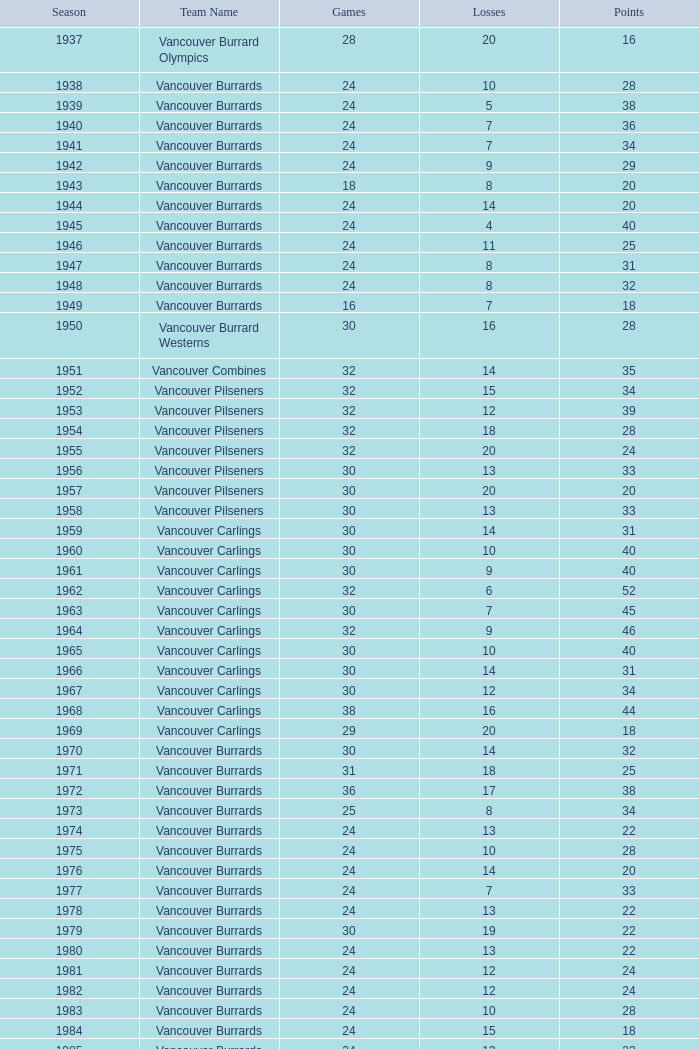Give me the full table as a dictionary. {'header': ['Season', 'Team Name', 'Games', 'Losses', 'Points'], 'rows': [['1937', 'Vancouver Burrard Olympics', '28', '20', '16'], ['1938', 'Vancouver Burrards', '24', '10', '28'], ['1939', 'Vancouver Burrards', '24', '5', '38'], ['1940', 'Vancouver Burrards', '24', '7', '36'], ['1941', 'Vancouver Burrards', '24', '7', '34'], ['1942', 'Vancouver Burrards', '24', '9', '29'], ['1943', 'Vancouver Burrards', '18', '8', '20'], ['1944', 'Vancouver Burrards', '24', '14', '20'], ['1945', 'Vancouver Burrards', '24', '4', '40'], ['1946', 'Vancouver Burrards', '24', '11', '25'], ['1947', 'Vancouver Burrards', '24', '8', '31'], ['1948', 'Vancouver Burrards', '24', '8', '32'], ['1949', 'Vancouver Burrards', '16', '7', '18'], ['1950', 'Vancouver Burrard Westerns', '30', '16', '28'], ['1951', 'Vancouver Combines', '32', '14', '35'], ['1952', 'Vancouver Pilseners', '32', '15', '34'], ['1953', 'Vancouver Pilseners', '32', '12', '39'], ['1954', 'Vancouver Pilseners', '32', '18', '28'], ['1955', 'Vancouver Pilseners', '32', '20', '24'], ['1956', 'Vancouver Pilseners', '30', '13', '33'], ['1957', 'Vancouver Pilseners', '30', '20', '20'], ['1958', 'Vancouver Pilseners', '30', '13', '33'], ['1959', 'Vancouver Carlings', '30', '14', '31'], ['1960', 'Vancouver Carlings', '30', '10', '40'], ['1961', 'Vancouver Carlings', '30', '9', '40'], ['1962', 'Vancouver Carlings', '32', '6', '52'], ['1963', 'Vancouver Carlings', '30', '7', '45'], ['1964', 'Vancouver Carlings', '32', '9', '46'], ['1965', 'Vancouver Carlings', '30', '10', '40'], ['1966', 'Vancouver Carlings', '30', '14', '31'], ['1967', 'Vancouver Carlings', '30', '12', '34'], ['1968', 'Vancouver Carlings', '38', '16', '44'], ['1969', 'Vancouver Carlings', '29', '20', '18'], ['1970', 'Vancouver Burrards', '30', '14', '32'], ['1971', 'Vancouver Burrards', '31', '18', '25'], ['1972', 'Vancouver Burrards', '36', '17', '38'], ['1973', 'Vancouver Burrards', '25', '8', '34'], ['1974', 'Vancouver Burrards', '24', '13', '22'], ['1975', 'Vancouver Burrards', '24', '10', '28'], ['1976', 'Vancouver Burrards', '24', '14', '20'], ['1977', 'Vancouver Burrards', '24', '7', '33'], ['1978', 'Vancouver Burrards', '24', '13', '22'], ['1979', 'Vancouver Burrards', '30', '19', '22'], ['1980', 'Vancouver Burrards', '24', '13', '22'], ['1981', 'Vancouver Burrards', '24', '12', '24'], ['1982', 'Vancouver Burrards', '24', '12', '24'], ['1983', 'Vancouver Burrards', '24', '10', '28'], ['1984', 'Vancouver Burrards', '24', '15', '18'], ['1985', 'Vancouver Burrards', '24', '13', '22'], ['1986', 'Vancouver Burrards', '24', '11', '26'], ['1987', 'Vancouver Burrards', '24', '14', '20'], ['1988', 'Vancouver Burrards', '24', '13', '22'], ['1989', 'Vancouver Burrards', '24', '15', '18'], ['1990', 'Vancouver Burrards', '24', '8', '32'], ['1991', 'Vancouver Burrards', '24', '16', '16'], ['1992', 'Vancouver Burrards', '24', '15', '18'], ['1993', 'Vancouver Burrards', '24', '20', '8'], ['1994', 'Surrey Burrards', '20', '12', '16'], ['1995', 'Surrey Burrards', '25', '19', '11'], ['1996', 'Maple Ridge Burrards', '20', '8', '23'], ['1997', 'Maple Ridge Burrards', '20', '8', '23'], ['1998', 'Maple Ridge Burrards', '25', '8', '32'], ['1999', 'Maple Ridge Burrards', '25', '15', '20'], ['2000', 'Maple Ridge Burrards', '25', '16', '18'], ['2001', 'Maple Ridge Burrards', '20', '16', '8'], ['2002', 'Maple Ridge Burrards', '20', '15', '8'], ['2003', 'Maple Ridge Burrards', '20', '15', '10'], ['2004', 'Maple Ridge Burrards', '20', '12', '16'], ['2005', 'Maple Ridge Burrards', '18', '8', '19'], ['2006', 'Maple Ridge Burrards', '18', '11', '14'], ['2007', 'Maple Ridge Burrards', '18', '11', '14'], ['2008', 'Maple Ridge Burrards', '18', '13', '10'], ['2009', 'Maple Ridge Burrards', '18', '11', '14'], ['2010', 'Maple Ridge Burrards', '18', '9', '18'], ['Total', '74 seasons', '1,879', '913', '1,916']]} What is the cumulative point count when the vancouver burrards experience under 9 losses and beyond 24 games? 1.0. 